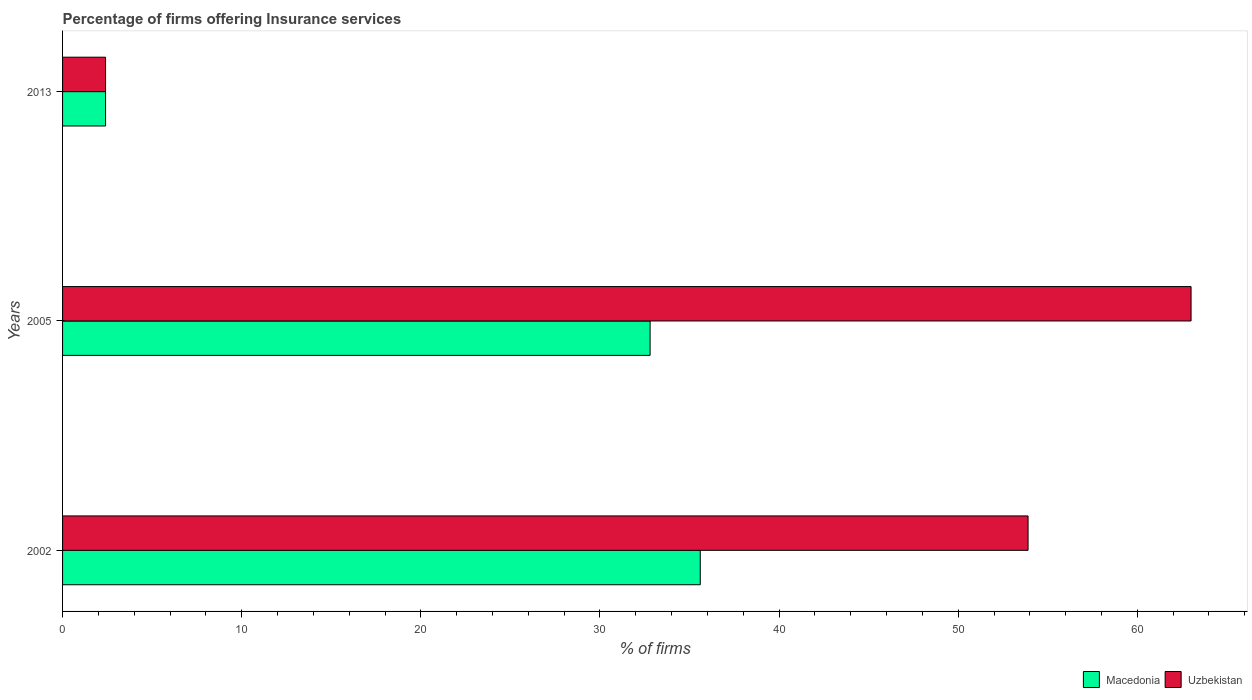How many different coloured bars are there?
Your answer should be very brief. 2. Are the number of bars per tick equal to the number of legend labels?
Make the answer very short. Yes. How many bars are there on the 1st tick from the bottom?
Provide a short and direct response. 2. In how many cases, is the number of bars for a given year not equal to the number of legend labels?
Ensure brevity in your answer.  0. What is the percentage of firms offering insurance services in Uzbekistan in 2013?
Provide a short and direct response. 2.4. Across all years, what is the maximum percentage of firms offering insurance services in Uzbekistan?
Ensure brevity in your answer.  63. Across all years, what is the minimum percentage of firms offering insurance services in Macedonia?
Your answer should be compact. 2.4. In which year was the percentage of firms offering insurance services in Uzbekistan minimum?
Offer a very short reply. 2013. What is the total percentage of firms offering insurance services in Uzbekistan in the graph?
Offer a terse response. 119.3. What is the difference between the percentage of firms offering insurance services in Uzbekistan in 2005 and that in 2013?
Your response must be concise. 60.6. What is the difference between the percentage of firms offering insurance services in Macedonia in 2005 and the percentage of firms offering insurance services in Uzbekistan in 2002?
Offer a very short reply. -21.1. What is the average percentage of firms offering insurance services in Uzbekistan per year?
Offer a very short reply. 39.77. What is the ratio of the percentage of firms offering insurance services in Uzbekistan in 2002 to that in 2005?
Your response must be concise. 0.86. What is the difference between the highest and the second highest percentage of firms offering insurance services in Macedonia?
Provide a short and direct response. 2.8. What is the difference between the highest and the lowest percentage of firms offering insurance services in Uzbekistan?
Offer a very short reply. 60.6. In how many years, is the percentage of firms offering insurance services in Macedonia greater than the average percentage of firms offering insurance services in Macedonia taken over all years?
Ensure brevity in your answer.  2. Is the sum of the percentage of firms offering insurance services in Macedonia in 2002 and 2013 greater than the maximum percentage of firms offering insurance services in Uzbekistan across all years?
Provide a succinct answer. No. What does the 1st bar from the top in 2005 represents?
Make the answer very short. Uzbekistan. What does the 1st bar from the bottom in 2002 represents?
Offer a terse response. Macedonia. Are the values on the major ticks of X-axis written in scientific E-notation?
Give a very brief answer. No. Does the graph contain grids?
Your answer should be very brief. No. Where does the legend appear in the graph?
Make the answer very short. Bottom right. What is the title of the graph?
Provide a succinct answer. Percentage of firms offering Insurance services. Does "High income: nonOECD" appear as one of the legend labels in the graph?
Your response must be concise. No. What is the label or title of the X-axis?
Ensure brevity in your answer.  % of firms. What is the % of firms of Macedonia in 2002?
Your answer should be compact. 35.6. What is the % of firms in Uzbekistan in 2002?
Provide a succinct answer. 53.9. What is the % of firms of Macedonia in 2005?
Your response must be concise. 32.8. Across all years, what is the maximum % of firms in Macedonia?
Offer a very short reply. 35.6. Across all years, what is the maximum % of firms in Uzbekistan?
Provide a short and direct response. 63. Across all years, what is the minimum % of firms of Uzbekistan?
Your answer should be compact. 2.4. What is the total % of firms in Macedonia in the graph?
Provide a short and direct response. 70.8. What is the total % of firms of Uzbekistan in the graph?
Your response must be concise. 119.3. What is the difference between the % of firms in Macedonia in 2002 and that in 2005?
Make the answer very short. 2.8. What is the difference between the % of firms in Uzbekistan in 2002 and that in 2005?
Provide a short and direct response. -9.1. What is the difference between the % of firms in Macedonia in 2002 and that in 2013?
Keep it short and to the point. 33.2. What is the difference between the % of firms of Uzbekistan in 2002 and that in 2013?
Your response must be concise. 51.5. What is the difference between the % of firms of Macedonia in 2005 and that in 2013?
Ensure brevity in your answer.  30.4. What is the difference between the % of firms of Uzbekistan in 2005 and that in 2013?
Your response must be concise. 60.6. What is the difference between the % of firms in Macedonia in 2002 and the % of firms in Uzbekistan in 2005?
Offer a very short reply. -27.4. What is the difference between the % of firms of Macedonia in 2002 and the % of firms of Uzbekistan in 2013?
Your answer should be compact. 33.2. What is the difference between the % of firms in Macedonia in 2005 and the % of firms in Uzbekistan in 2013?
Your response must be concise. 30.4. What is the average % of firms of Macedonia per year?
Make the answer very short. 23.6. What is the average % of firms in Uzbekistan per year?
Your answer should be compact. 39.77. In the year 2002, what is the difference between the % of firms of Macedonia and % of firms of Uzbekistan?
Offer a very short reply. -18.3. In the year 2005, what is the difference between the % of firms in Macedonia and % of firms in Uzbekistan?
Give a very brief answer. -30.2. What is the ratio of the % of firms of Macedonia in 2002 to that in 2005?
Give a very brief answer. 1.09. What is the ratio of the % of firms of Uzbekistan in 2002 to that in 2005?
Ensure brevity in your answer.  0.86. What is the ratio of the % of firms of Macedonia in 2002 to that in 2013?
Your answer should be very brief. 14.83. What is the ratio of the % of firms of Uzbekistan in 2002 to that in 2013?
Your answer should be very brief. 22.46. What is the ratio of the % of firms in Macedonia in 2005 to that in 2013?
Offer a very short reply. 13.67. What is the ratio of the % of firms of Uzbekistan in 2005 to that in 2013?
Provide a succinct answer. 26.25. What is the difference between the highest and the lowest % of firms of Macedonia?
Keep it short and to the point. 33.2. What is the difference between the highest and the lowest % of firms in Uzbekistan?
Keep it short and to the point. 60.6. 